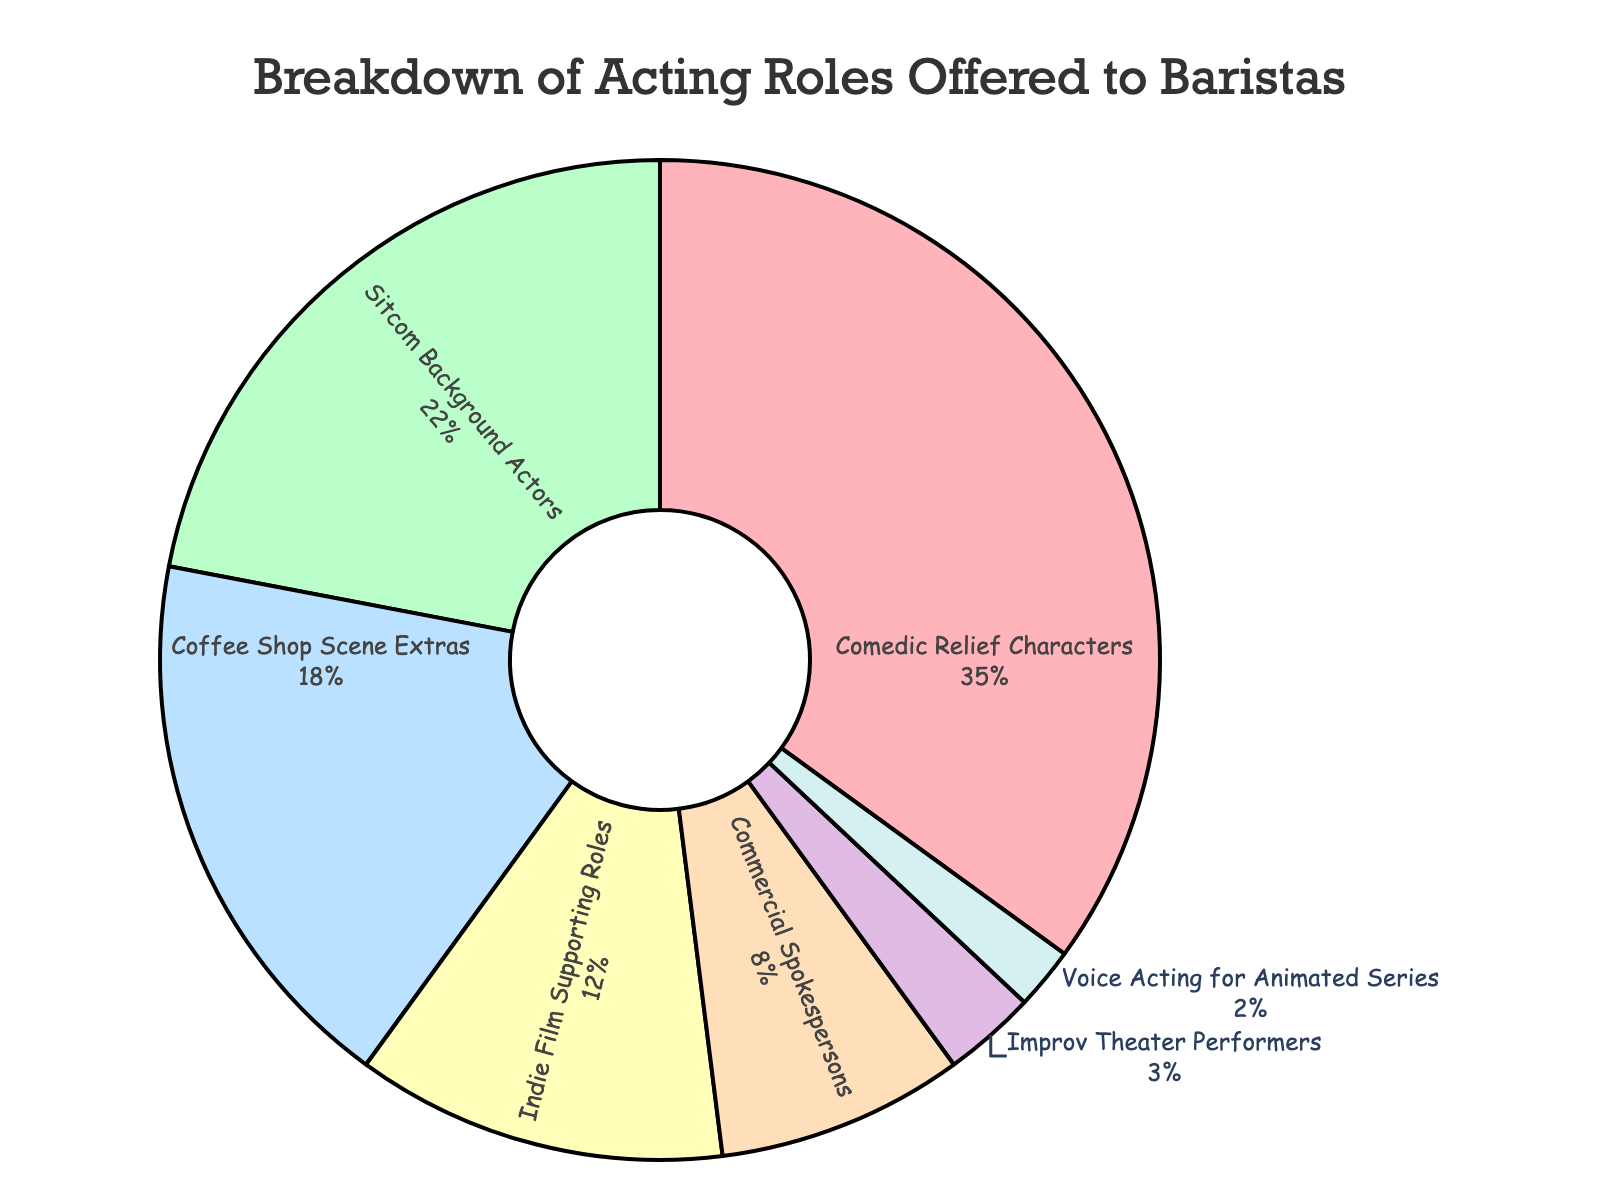What's the largest acting role category offered to baristas? The figure shows different role categories with their corresponding percentages. The largest portion of the pie chart represents "Comedic Relief Characters" with 35%.
Answer: Comedic Relief Characters Which two categories combined make up 40% of the acting roles? Referring to the pie chart, "Sitcom Background Actors" (22%) and "Coffee Shop Scene Extras" (18%) combined sum up to 40%.
Answer: Sitcom Background Actors and Coffee Shop Scene Extras What's the percentage difference between the largest and smallest categories? The largest category is "Comedic Relief Characters" with 35%, and the smallest is "Voice Acting for Animated Series" with 2%. The difference is 35% - 2% = 33%.
Answer: 33% Are there more baristas offered roles in "Indie Film Supporting Roles" or "Commercial Spokespersons"? The pie chart shows "Indie Film Supporting Roles" at 12% and "Commercial Spokespersons" at 8%. Therefore, there are more baristas offered roles in "Indie Film Supporting Roles".
Answer: Indie Film Supporting Roles Which category has a smaller percentage than "Indie Film Supporting Roles" but larger than "Improv Theater Performers"? "Commercial Spokespersons" is between "Indie Film Supporting Roles" (12%) and "Improv Theater Performers" (3%) with 8%.
Answer: Commercial Spokespersons How many categories have a percentage lower than 10%? According to the pie chart, the categories "Commercial Spokespersons" (8%), "Improv Theater Performers" (3%), and "Voice Acting for Animated Series" (2%) are all below 10%. There are 3 such categories.
Answer: 3 What is the total percentage of roles that are extras or performers in various scenes? The relevant categories are "Sitcom Background Actors" (22%), "Coffee Shop Scene Extras" (18%), and "Improv Theater Performers" (3%). Their total percentage is 22% + 18% + 3% = 43%.
Answer: 43% Which visual attribute helps identify the category with 18% of roles? The category with an 18% share is "Coffee Shop Scene Extras". This section is visually distinguished by its color and size on the pie chart.
Answer: Coffee Shop Scene Extras Which two categories combined almost equal the percentage of "Comedic Relief Characters"? "Sitcom Background Actors" (22%) and "Indie Film Supporting Roles" (12%) together add up to 34%, which is close to "Comedic Relief Characters" at 35%.
Answer: Sitcom Background Actors and Indie Film Supporting Roles Is the portion of roles for "Voice Acting for Animated Series" smaller than that for "Improv Theater Performers"? The chart shows "Voice Acting for Animated Series" at 2% and "Improv Theater Performers" at 3%, indicating that the portion for "Voice Acting for Animated Series" is indeed smaller.
Answer: Yes 